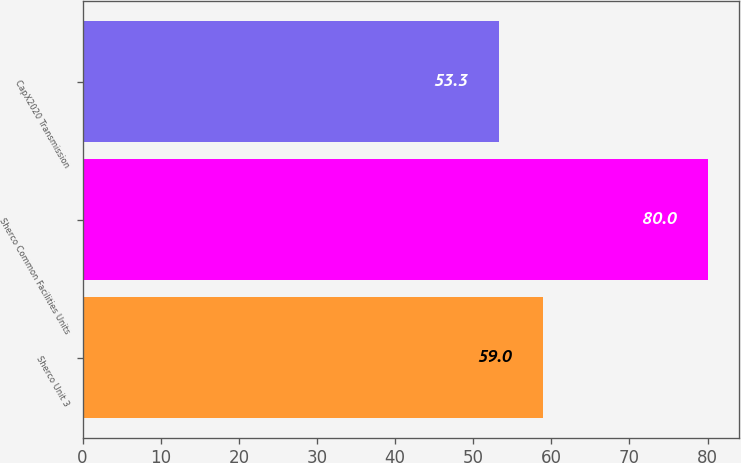Convert chart to OTSL. <chart><loc_0><loc_0><loc_500><loc_500><bar_chart><fcel>Sherco Unit 3<fcel>Sherco Common Facilities Units<fcel>CapX2020 Transmission<nl><fcel>59<fcel>80<fcel>53.3<nl></chart> 